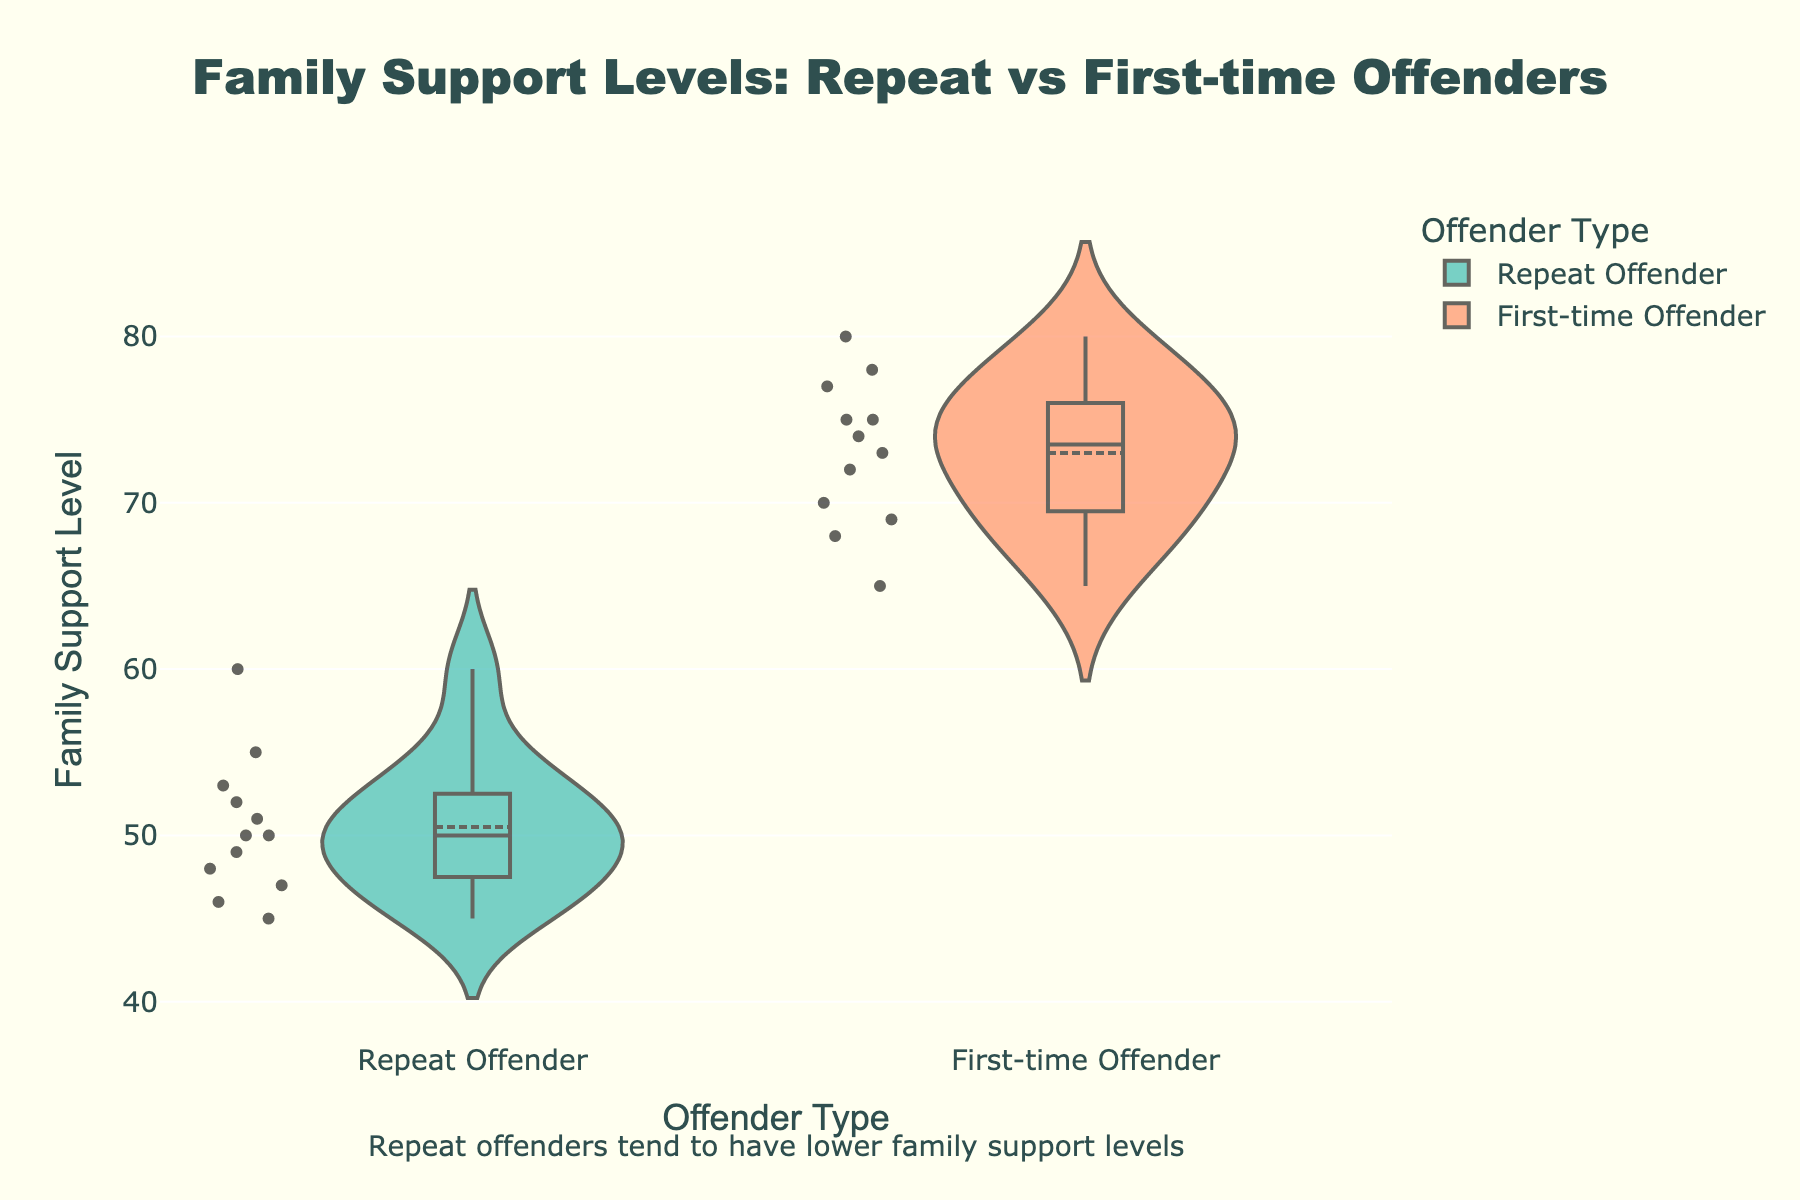What's the title of the figure? The title is centered at the top of the chart. It reads "Family Support Levels: Repeat vs First-time Offenders".
Answer: Family Support Levels: Repeat vs First-time Offenders What does the x-axis represent? The x-axis represents the type of offender. The categories are 'Repeat Offender' and 'First-time Offender'.
Answer: Offender Type How many data points are there for Repeat Offenders? Each dot on the violin plot represents a data point. Counting these for Repeat Offenders, we find there are 12 data points.
Answer: 12 Which offender type generally has higher family support levels? By comparing the median lines and distribution along the y-axis, First-time Offenders generally have higher family support levels.
Answer: First-time Offenders What's the color used for the Repeat Offenders? The Repeat Offenders are represented with a 'lightseagreen' fill color.
Answer: lightseagreen What is the approximate median family support level for First-time Offenders? The box plot within the violin plot shows the median value. For First-time Offenders, it's indicated at approximately 73.
Answer: 73 What’s the mean family support level for Repeat Offenders? The mean line inside the box plot indicates the mean of the distribution. For Repeat Offenders, it is around 50.
Answer: 50 Between the two offender types, which one has a larger spread in family support levels? Observing the width and range of the violin plots, First-time Offenders have a larger spread from approximately 65 to 80.
Answer: First-time Offenders How do the interquartile ranges compare between the two groups? The interquartile range (IQR) is represented by the height of the boxes. Comparing the boxes, First-time Offenders have a larger IQR than Repeat Offenders.
Answer: First-time Offenders have a larger IQR Which annotation is included in the plot? Below the plot, there's an annotation that reads "Repeat offenders tend to have lower family support levels".
Answer: Repeat offenders tend to have lower family support levels 